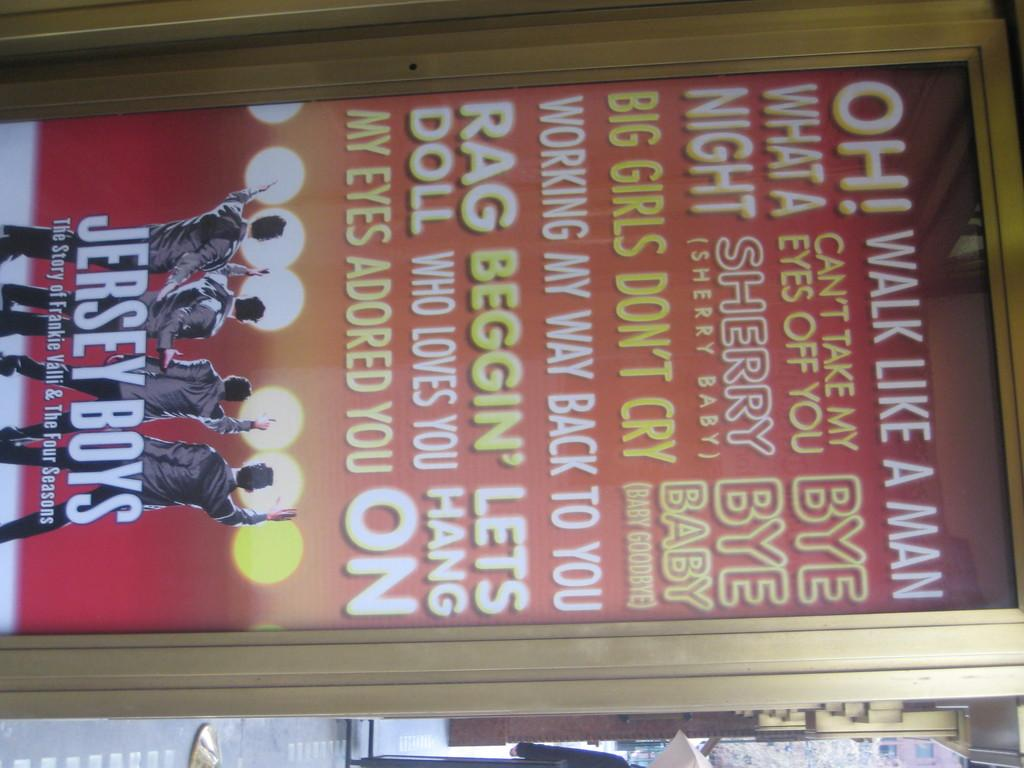<image>
Describe the image concisely. A framed poster for the Jersey Boys movie, many songs listed on the poster like Rag Doll and Big girls don't cry 